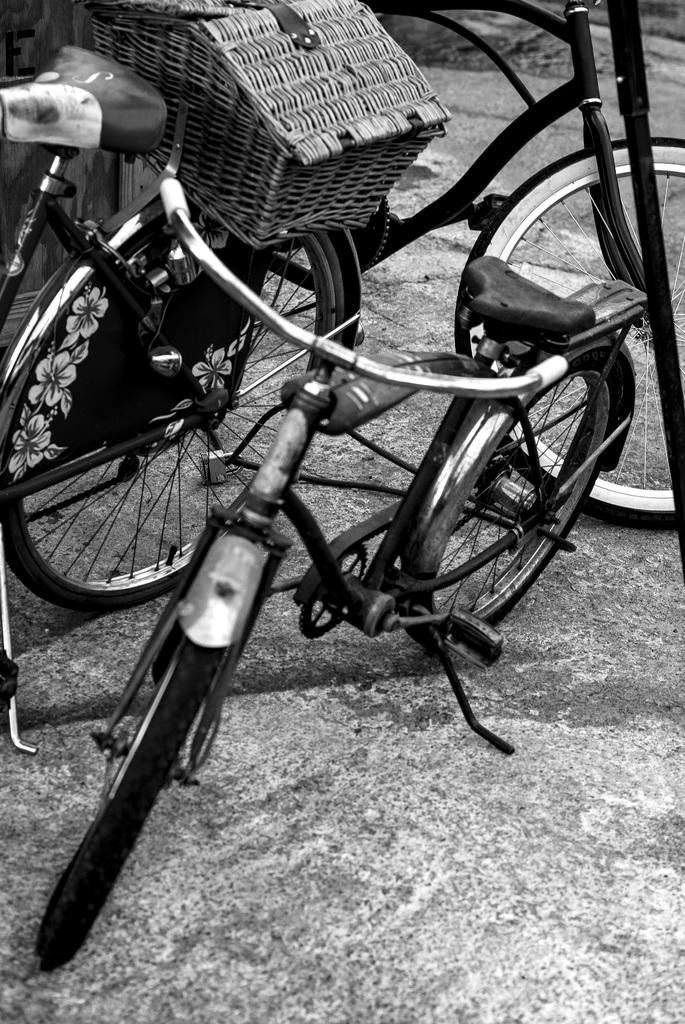What type of vehicles are on the road in the image? There are bicycles on the road in the image. Are there any specific features on any of the bicycles? Yes, one of the bicycles has a basket on it. What type of marble is used to decorate the handlebars of the bicycles in the image? There is no marble present on the bicycles in the image; they are not decorated with marble. 